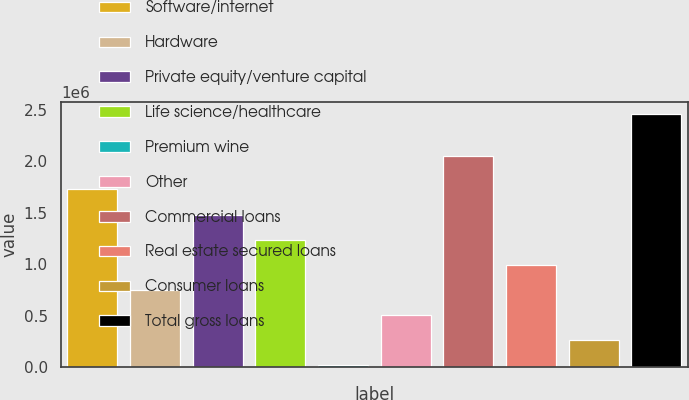Convert chart to OTSL. <chart><loc_0><loc_0><loc_500><loc_500><bar_chart><fcel>Software/internet<fcel>Hardware<fcel>Private equity/venture capital<fcel>Life science/healthcare<fcel>Premium wine<fcel>Other<fcel>Commercial loans<fcel>Real estate secured loans<fcel>Consumer loans<fcel>Total gross loans<nl><fcel>1.72462e+06<fcel>753530<fcel>1.48185e+06<fcel>1.23908e+06<fcel>25209<fcel>510756<fcel>2.04785e+06<fcel>996303<fcel>267983<fcel>2.45294e+06<nl></chart> 